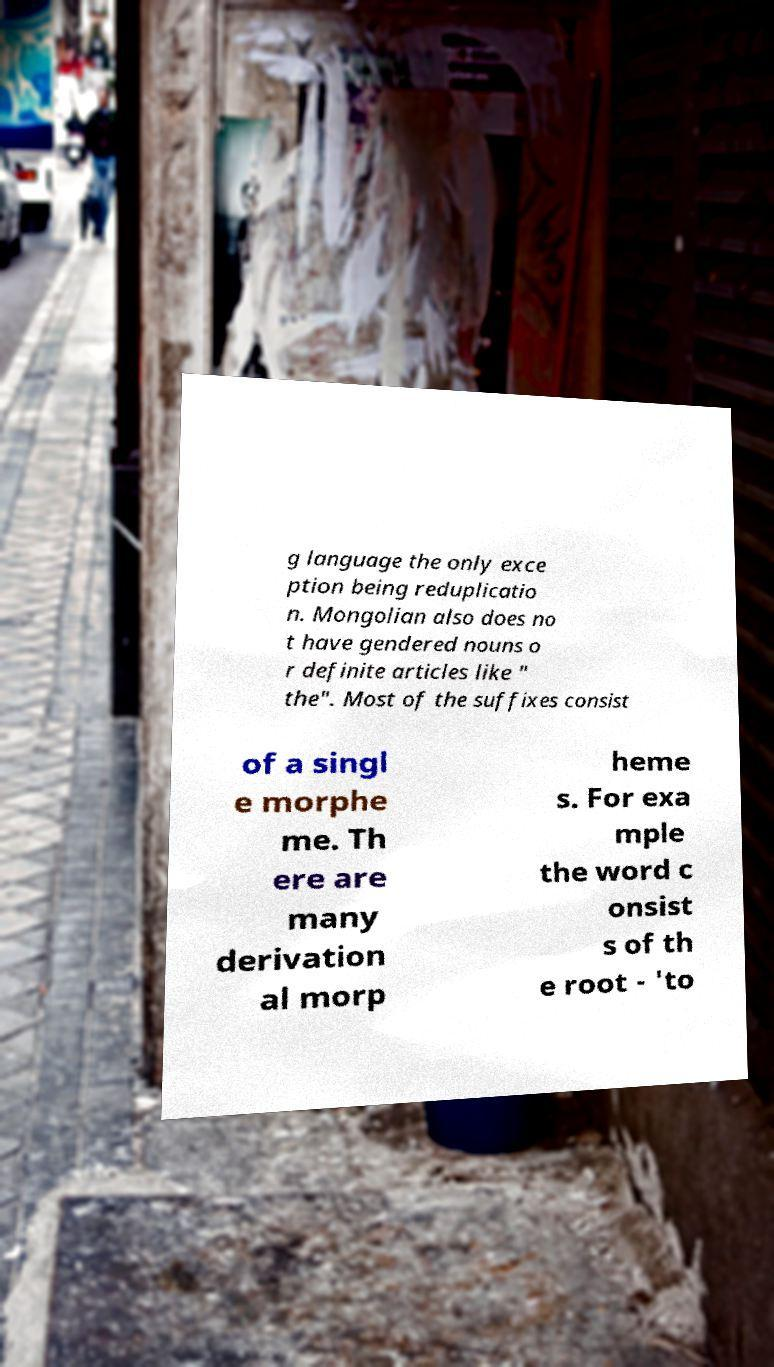I need the written content from this picture converted into text. Can you do that? g language the only exce ption being reduplicatio n. Mongolian also does no t have gendered nouns o r definite articles like " the". Most of the suffixes consist of a singl e morphe me. Th ere are many derivation al morp heme s. For exa mple the word c onsist s of th e root - 'to 